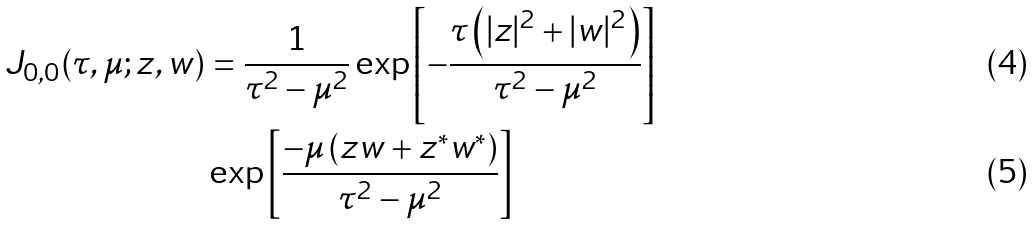<formula> <loc_0><loc_0><loc_500><loc_500>J _ { 0 , 0 } ( \tau , \mu ; z , w ) & = \frac { 1 } { \tau ^ { 2 } - \mu ^ { 2 } } \exp \left [ - \frac { \tau \left ( | z | ^ { 2 } + | w | ^ { 2 } \right ) } { \tau ^ { 2 } - \mu ^ { 2 } } \right ] \\ & \exp \left [ \frac { - \mu \left ( z w + z ^ { \ast } w ^ { \ast } \right ) } { \tau ^ { 2 } - \mu ^ { 2 } } \right ]</formula> 